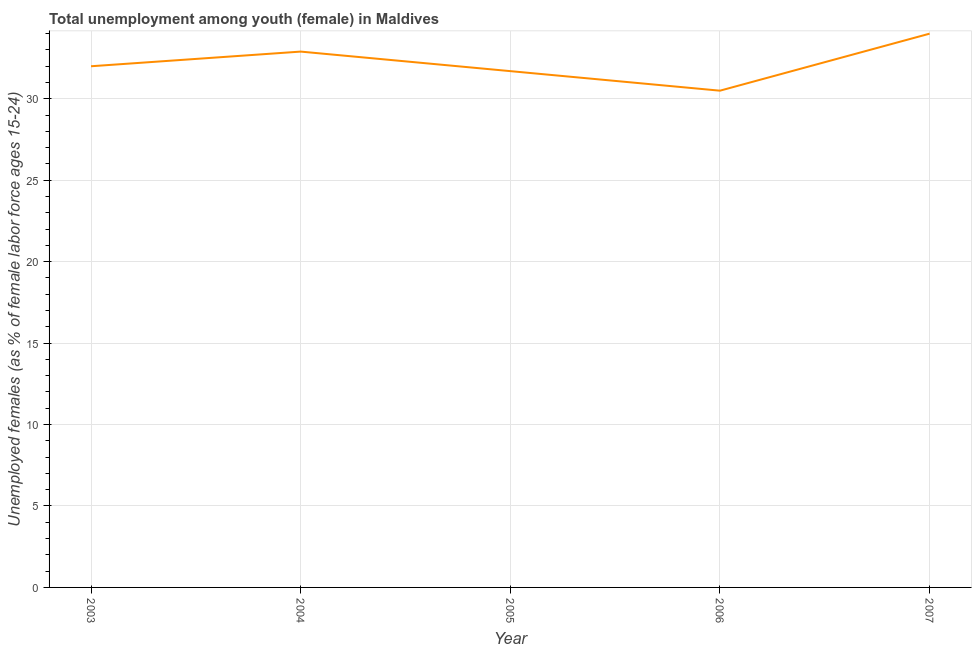What is the unemployed female youth population in 2004?
Your response must be concise. 32.9. Across all years, what is the maximum unemployed female youth population?
Give a very brief answer. 34. Across all years, what is the minimum unemployed female youth population?
Offer a very short reply. 30.5. In which year was the unemployed female youth population minimum?
Your answer should be compact. 2006. What is the sum of the unemployed female youth population?
Offer a very short reply. 161.1. What is the difference between the unemployed female youth population in 2004 and 2006?
Ensure brevity in your answer.  2.4. What is the average unemployed female youth population per year?
Your answer should be very brief. 32.22. Do a majority of the years between 2004 and 2003 (inclusive) have unemployed female youth population greater than 22 %?
Offer a very short reply. No. What is the ratio of the unemployed female youth population in 2003 to that in 2007?
Provide a succinct answer. 0.94. Is the unemployed female youth population in 2006 less than that in 2007?
Your answer should be compact. Yes. What is the difference between the highest and the second highest unemployed female youth population?
Your answer should be compact. 1.1. Is the sum of the unemployed female youth population in 2003 and 2007 greater than the maximum unemployed female youth population across all years?
Ensure brevity in your answer.  Yes. What is the difference between the highest and the lowest unemployed female youth population?
Give a very brief answer. 3.5. Does the unemployed female youth population monotonically increase over the years?
Provide a succinct answer. No. How many years are there in the graph?
Offer a terse response. 5. Are the values on the major ticks of Y-axis written in scientific E-notation?
Offer a terse response. No. What is the title of the graph?
Keep it short and to the point. Total unemployment among youth (female) in Maldives. What is the label or title of the X-axis?
Your response must be concise. Year. What is the label or title of the Y-axis?
Keep it short and to the point. Unemployed females (as % of female labor force ages 15-24). What is the Unemployed females (as % of female labor force ages 15-24) of 2004?
Keep it short and to the point. 32.9. What is the Unemployed females (as % of female labor force ages 15-24) of 2005?
Provide a succinct answer. 31.7. What is the Unemployed females (as % of female labor force ages 15-24) in 2006?
Offer a very short reply. 30.5. What is the difference between the Unemployed females (as % of female labor force ages 15-24) in 2003 and 2005?
Your answer should be very brief. 0.3. What is the difference between the Unemployed females (as % of female labor force ages 15-24) in 2003 and 2006?
Offer a terse response. 1.5. What is the difference between the Unemployed females (as % of female labor force ages 15-24) in 2004 and 2005?
Give a very brief answer. 1.2. What is the difference between the Unemployed females (as % of female labor force ages 15-24) in 2004 and 2007?
Your response must be concise. -1.1. What is the difference between the Unemployed females (as % of female labor force ages 15-24) in 2005 and 2006?
Offer a very short reply. 1.2. What is the difference between the Unemployed females (as % of female labor force ages 15-24) in 2005 and 2007?
Offer a terse response. -2.3. What is the difference between the Unemployed females (as % of female labor force ages 15-24) in 2006 and 2007?
Offer a terse response. -3.5. What is the ratio of the Unemployed females (as % of female labor force ages 15-24) in 2003 to that in 2004?
Offer a very short reply. 0.97. What is the ratio of the Unemployed females (as % of female labor force ages 15-24) in 2003 to that in 2006?
Offer a terse response. 1.05. What is the ratio of the Unemployed females (as % of female labor force ages 15-24) in 2003 to that in 2007?
Your answer should be compact. 0.94. What is the ratio of the Unemployed females (as % of female labor force ages 15-24) in 2004 to that in 2005?
Give a very brief answer. 1.04. What is the ratio of the Unemployed females (as % of female labor force ages 15-24) in 2004 to that in 2006?
Give a very brief answer. 1.08. What is the ratio of the Unemployed females (as % of female labor force ages 15-24) in 2005 to that in 2006?
Your response must be concise. 1.04. What is the ratio of the Unemployed females (as % of female labor force ages 15-24) in 2005 to that in 2007?
Offer a very short reply. 0.93. What is the ratio of the Unemployed females (as % of female labor force ages 15-24) in 2006 to that in 2007?
Give a very brief answer. 0.9. 